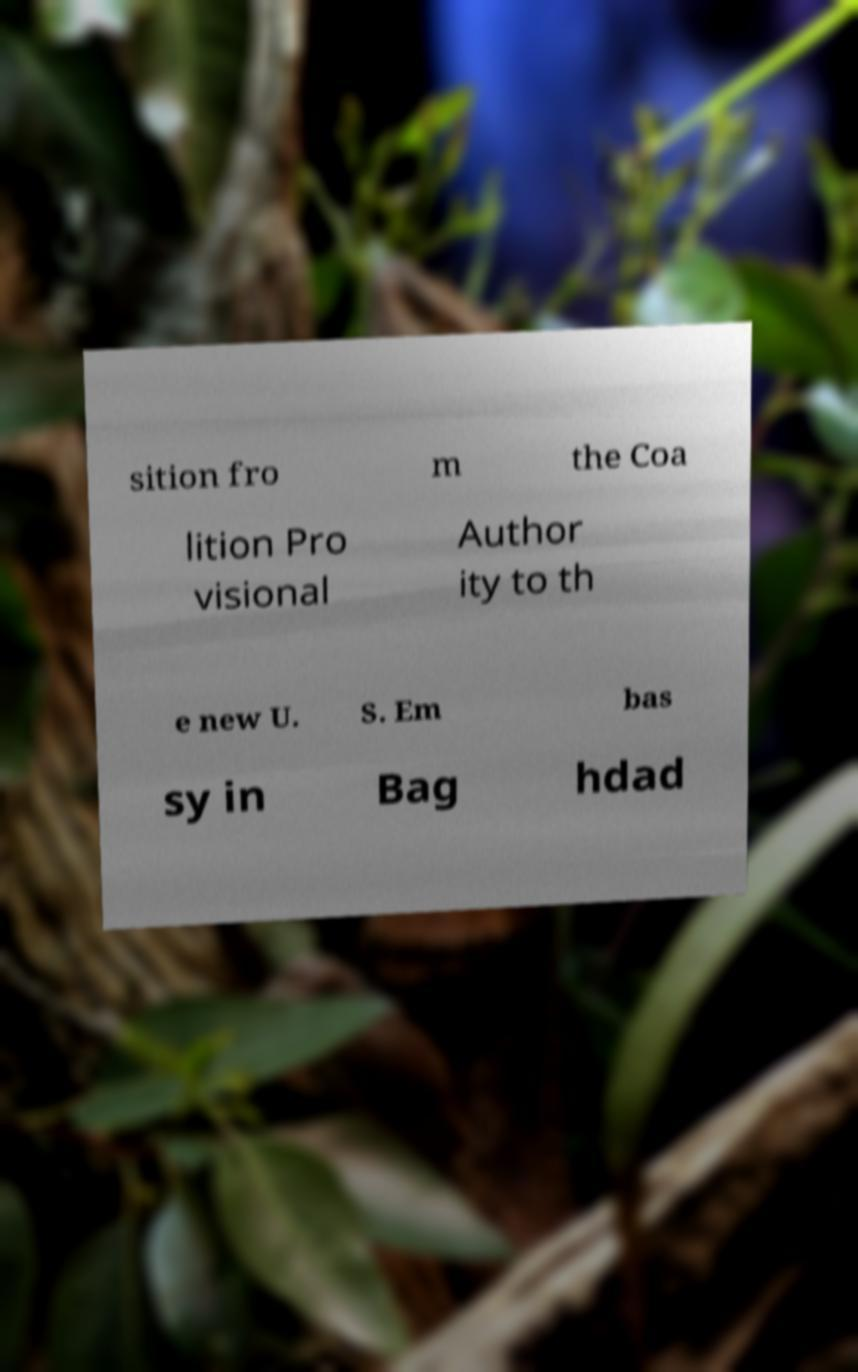Can you accurately transcribe the text from the provided image for me? sition fro m the Coa lition Pro visional Author ity to th e new U. S. Em bas sy in Bag hdad 